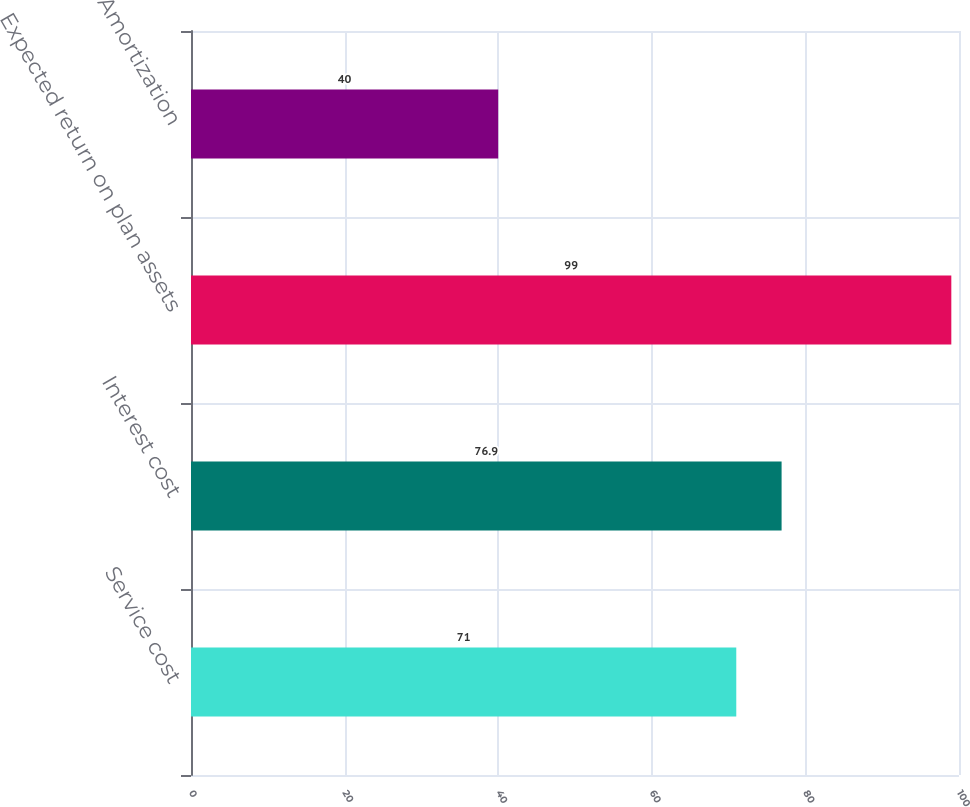<chart> <loc_0><loc_0><loc_500><loc_500><bar_chart><fcel>Service cost<fcel>Interest cost<fcel>Expected return on plan assets<fcel>Amortization<nl><fcel>71<fcel>76.9<fcel>99<fcel>40<nl></chart> 